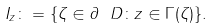Convert formula to latex. <formula><loc_0><loc_0><loc_500><loc_500>I _ { z } \colon = \{ \zeta \in \partial \ D \colon z \in \Gamma ( \zeta ) \} .</formula> 